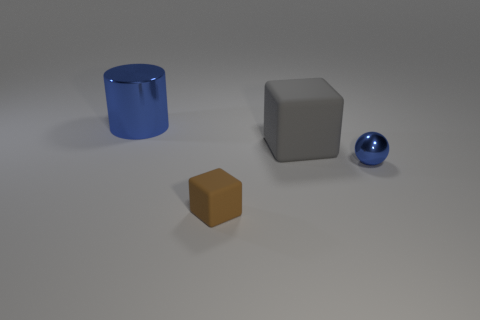Add 2 blue spheres. How many objects exist? 6 Subtract all balls. How many objects are left? 3 Add 1 yellow rubber cylinders. How many yellow rubber cylinders exist? 1 Subtract 0 cyan blocks. How many objects are left? 4 Subtract all large cyan metallic spheres. Subtract all small shiny objects. How many objects are left? 3 Add 3 small brown rubber cubes. How many small brown rubber cubes are left? 4 